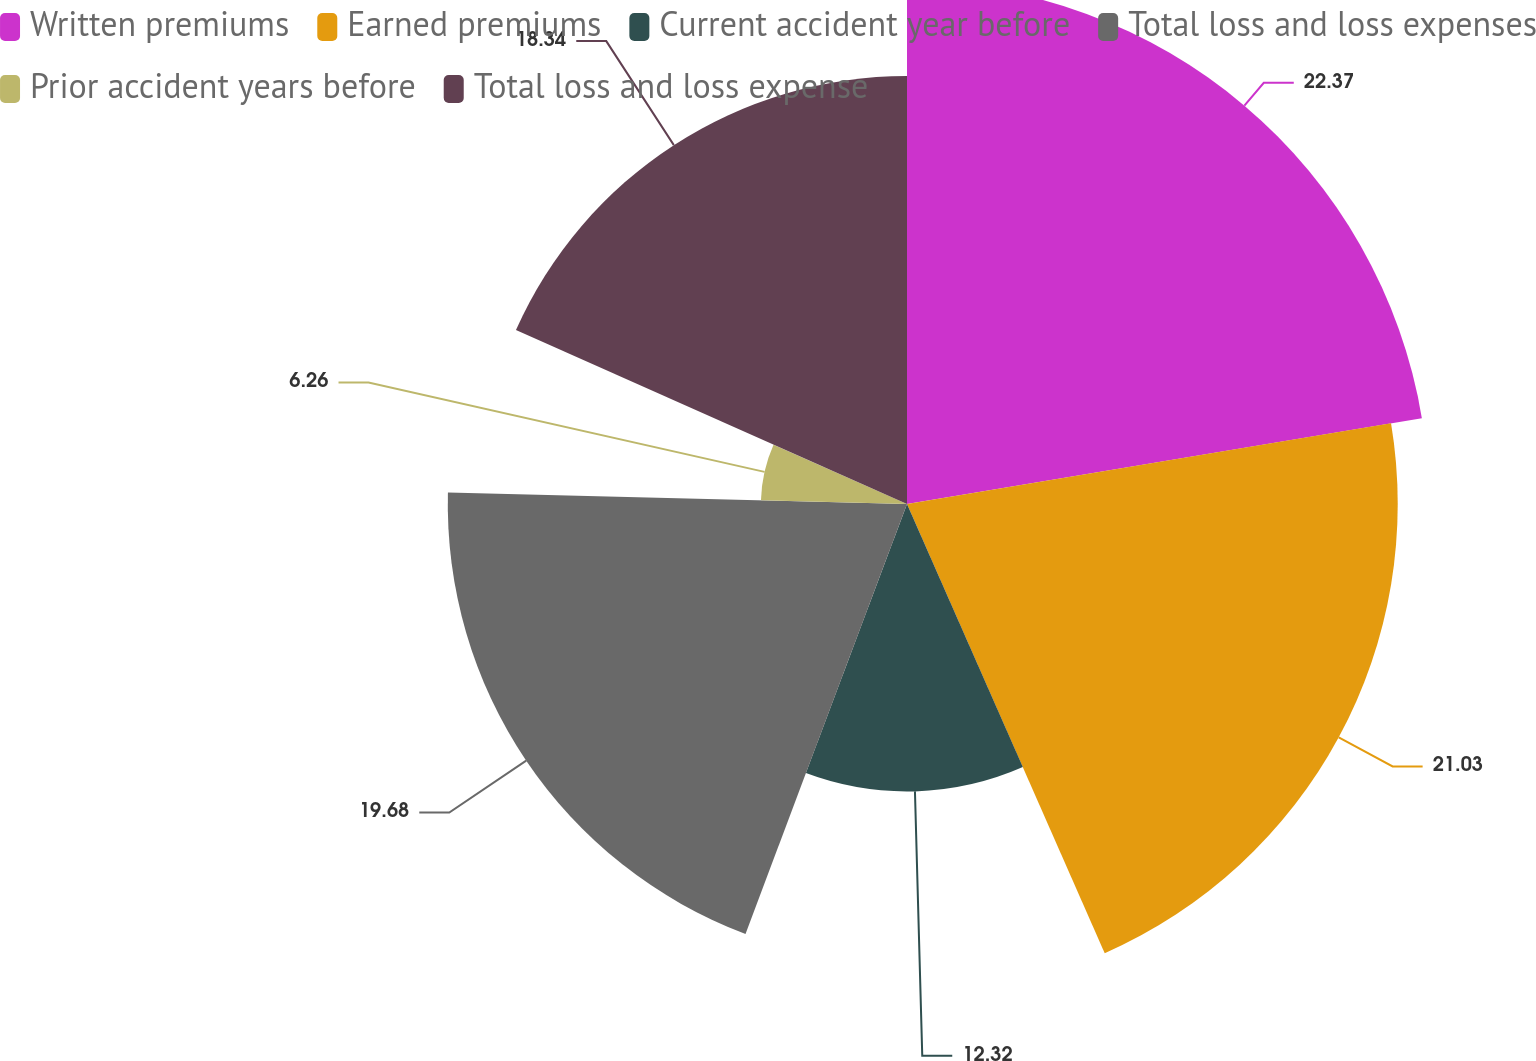Convert chart. <chart><loc_0><loc_0><loc_500><loc_500><pie_chart><fcel>Written premiums<fcel>Earned premiums<fcel>Current accident year before<fcel>Total loss and loss expenses<fcel>Prior accident years before<fcel>Total loss and loss expense<nl><fcel>22.37%<fcel>21.03%<fcel>12.32%<fcel>19.68%<fcel>6.26%<fcel>18.34%<nl></chart> 